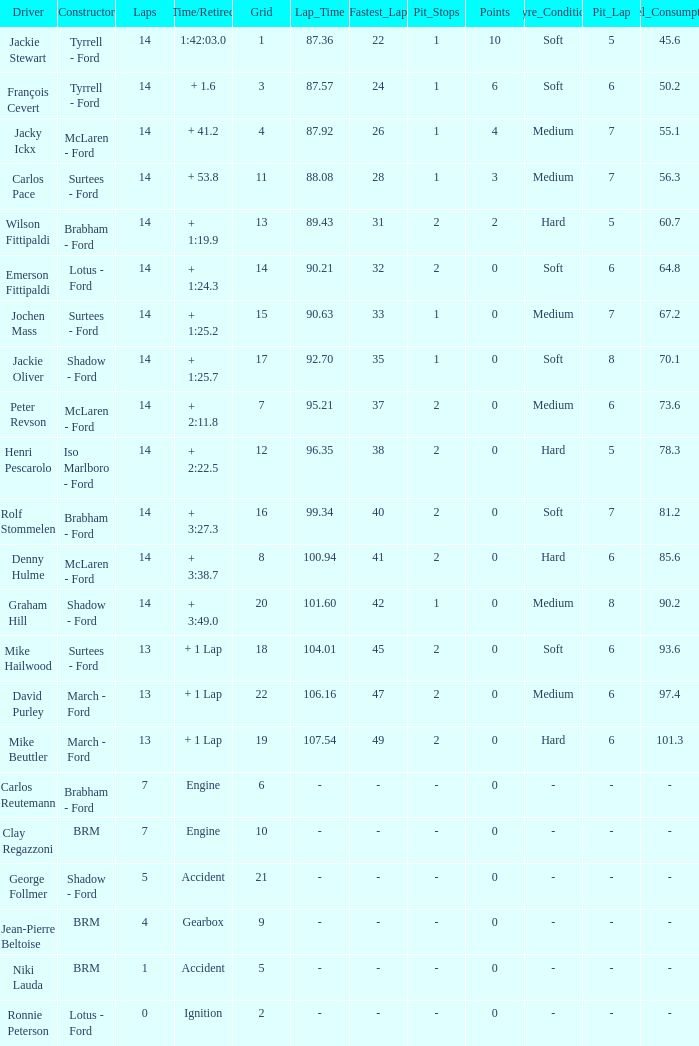What grad has a Time/Retired of + 1:24.3? 14.0. 